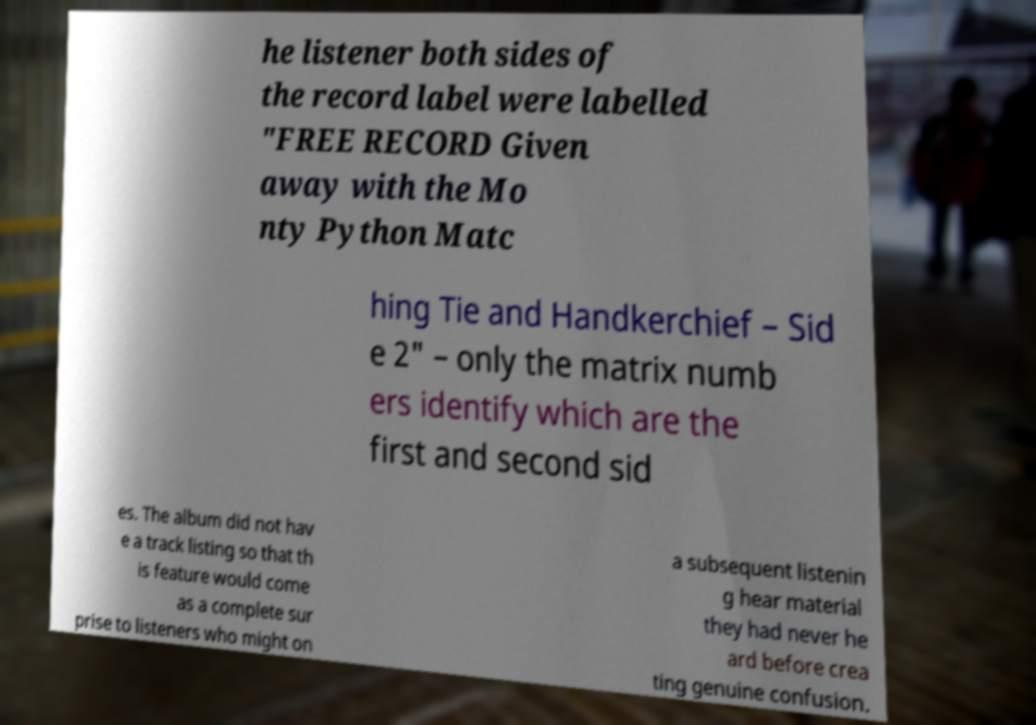What messages or text are displayed in this image? I need them in a readable, typed format. he listener both sides of the record label were labelled "FREE RECORD Given away with the Mo nty Python Matc hing Tie and Handkerchief – Sid e 2" – only the matrix numb ers identify which are the first and second sid es. The album did not hav e a track listing so that th is feature would come as a complete sur prise to listeners who might on a subsequent listenin g hear material they had never he ard before crea ting genuine confusion. 